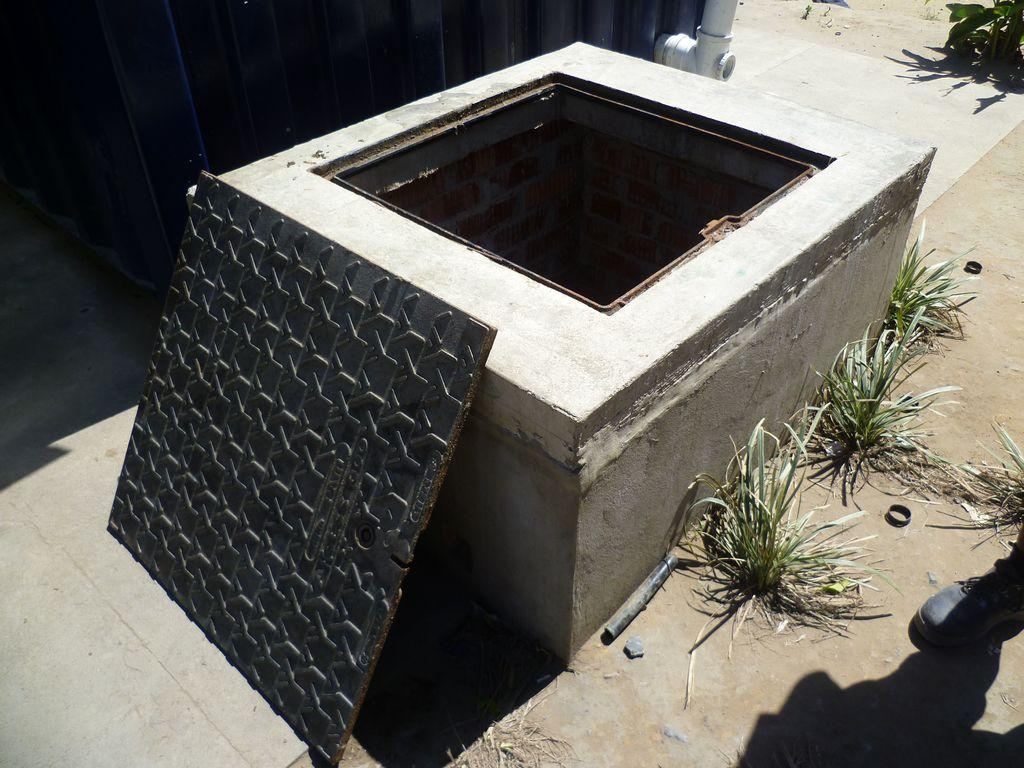What is the main subject in the foreground of the image? There is a manhole and its lid in the foreground of the image. Can you describe any human presence in the image? A person's leg is visible on the right side of the image. What type of vegetation is present in the image? Grass is present on the ground. What other objects can be seen in the image? There is a pipe and a metal sheet visible in the image. What type of stove is being used at the party in the image? There is no stove or party present in the image; it features a manhole, a person's leg, grass, a pipe, and a metal sheet. 